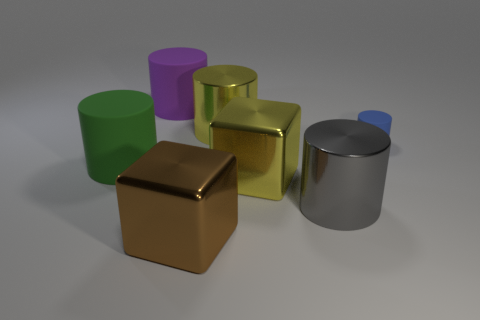Subtract all blue cylinders. How many cylinders are left? 4 Subtract all large purple matte cylinders. How many cylinders are left? 4 Subtract all cyan cylinders. Subtract all red spheres. How many cylinders are left? 5 Add 1 big blocks. How many objects exist? 8 Subtract all blocks. How many objects are left? 5 Subtract all tiny blue matte cylinders. Subtract all yellow objects. How many objects are left? 4 Add 7 big metallic cylinders. How many big metallic cylinders are left? 9 Add 6 tiny yellow metal spheres. How many tiny yellow metal spheres exist? 6 Subtract 1 gray cylinders. How many objects are left? 6 